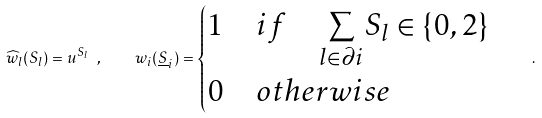<formula> <loc_0><loc_0><loc_500><loc_500>\widehat { w } _ { l } ( S _ { l } ) = u ^ { S _ { l } } \ , \quad w _ { i } ( \underline { S } _ { i } ) = \begin{cases} 1 \quad i f \quad \underset { l \in \partial i } { \sum } S _ { l } \in \{ 0 , 2 \} \\ 0 \quad o t h e r w i s e \end{cases} \ .</formula> 